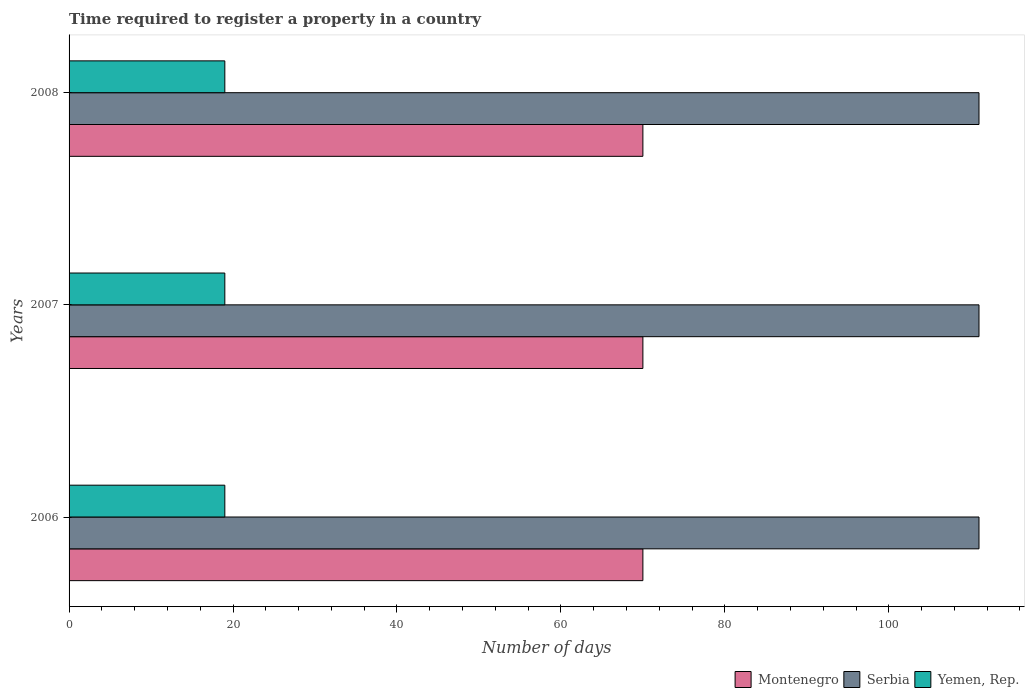How many different coloured bars are there?
Ensure brevity in your answer.  3. How many groups of bars are there?
Make the answer very short. 3. Are the number of bars per tick equal to the number of legend labels?
Your answer should be compact. Yes. Are the number of bars on each tick of the Y-axis equal?
Offer a very short reply. Yes. How many bars are there on the 2nd tick from the top?
Give a very brief answer. 3. How many bars are there on the 2nd tick from the bottom?
Offer a terse response. 3. In how many cases, is the number of bars for a given year not equal to the number of legend labels?
Make the answer very short. 0. What is the number of days required to register a property in Yemen, Rep. in 2006?
Make the answer very short. 19. Across all years, what is the maximum number of days required to register a property in Serbia?
Your answer should be very brief. 111. Across all years, what is the minimum number of days required to register a property in Serbia?
Ensure brevity in your answer.  111. What is the total number of days required to register a property in Yemen, Rep. in the graph?
Make the answer very short. 57. In the year 2008, what is the difference between the number of days required to register a property in Montenegro and number of days required to register a property in Serbia?
Provide a succinct answer. -41. In how many years, is the number of days required to register a property in Yemen, Rep. greater than 12 days?
Your answer should be very brief. 3. Is the number of days required to register a property in Serbia in 2007 less than that in 2008?
Provide a succinct answer. No. Is the difference between the number of days required to register a property in Montenegro in 2006 and 2008 greater than the difference between the number of days required to register a property in Serbia in 2006 and 2008?
Give a very brief answer. No. What is the difference between the highest and the lowest number of days required to register a property in Yemen, Rep.?
Offer a very short reply. 0. Is the sum of the number of days required to register a property in Yemen, Rep. in 2007 and 2008 greater than the maximum number of days required to register a property in Montenegro across all years?
Give a very brief answer. No. What does the 1st bar from the top in 2006 represents?
Your response must be concise. Yemen, Rep. What does the 3rd bar from the bottom in 2008 represents?
Provide a short and direct response. Yemen, Rep. Is it the case that in every year, the sum of the number of days required to register a property in Serbia and number of days required to register a property in Montenegro is greater than the number of days required to register a property in Yemen, Rep.?
Provide a short and direct response. Yes. What is the difference between two consecutive major ticks on the X-axis?
Offer a very short reply. 20. Does the graph contain grids?
Offer a terse response. No. Where does the legend appear in the graph?
Keep it short and to the point. Bottom right. How many legend labels are there?
Provide a succinct answer. 3. What is the title of the graph?
Ensure brevity in your answer.  Time required to register a property in a country. What is the label or title of the X-axis?
Ensure brevity in your answer.  Number of days. What is the label or title of the Y-axis?
Ensure brevity in your answer.  Years. What is the Number of days of Serbia in 2006?
Provide a succinct answer. 111. What is the Number of days of Yemen, Rep. in 2006?
Keep it short and to the point. 19. What is the Number of days in Montenegro in 2007?
Give a very brief answer. 70. What is the Number of days in Serbia in 2007?
Keep it short and to the point. 111. What is the Number of days of Montenegro in 2008?
Provide a succinct answer. 70. What is the Number of days in Serbia in 2008?
Ensure brevity in your answer.  111. Across all years, what is the maximum Number of days in Serbia?
Offer a terse response. 111. Across all years, what is the minimum Number of days of Montenegro?
Ensure brevity in your answer.  70. Across all years, what is the minimum Number of days in Serbia?
Provide a short and direct response. 111. Across all years, what is the minimum Number of days of Yemen, Rep.?
Provide a short and direct response. 19. What is the total Number of days of Montenegro in the graph?
Provide a short and direct response. 210. What is the total Number of days in Serbia in the graph?
Make the answer very short. 333. What is the difference between the Number of days in Montenegro in 2006 and that in 2007?
Make the answer very short. 0. What is the difference between the Number of days in Serbia in 2006 and that in 2007?
Your answer should be compact. 0. What is the difference between the Number of days of Yemen, Rep. in 2006 and that in 2007?
Your answer should be compact. 0. What is the difference between the Number of days of Montenegro in 2006 and that in 2008?
Offer a terse response. 0. What is the difference between the Number of days of Serbia in 2006 and that in 2008?
Your response must be concise. 0. What is the difference between the Number of days of Yemen, Rep. in 2006 and that in 2008?
Keep it short and to the point. 0. What is the difference between the Number of days in Montenegro in 2007 and that in 2008?
Your answer should be compact. 0. What is the difference between the Number of days of Yemen, Rep. in 2007 and that in 2008?
Keep it short and to the point. 0. What is the difference between the Number of days of Montenegro in 2006 and the Number of days of Serbia in 2007?
Offer a very short reply. -41. What is the difference between the Number of days of Serbia in 2006 and the Number of days of Yemen, Rep. in 2007?
Provide a short and direct response. 92. What is the difference between the Number of days in Montenegro in 2006 and the Number of days in Serbia in 2008?
Offer a very short reply. -41. What is the difference between the Number of days of Serbia in 2006 and the Number of days of Yemen, Rep. in 2008?
Offer a terse response. 92. What is the difference between the Number of days in Montenegro in 2007 and the Number of days in Serbia in 2008?
Your answer should be compact. -41. What is the difference between the Number of days in Serbia in 2007 and the Number of days in Yemen, Rep. in 2008?
Offer a very short reply. 92. What is the average Number of days in Montenegro per year?
Provide a succinct answer. 70. What is the average Number of days of Serbia per year?
Offer a terse response. 111. What is the average Number of days in Yemen, Rep. per year?
Give a very brief answer. 19. In the year 2006, what is the difference between the Number of days of Montenegro and Number of days of Serbia?
Ensure brevity in your answer.  -41. In the year 2006, what is the difference between the Number of days of Serbia and Number of days of Yemen, Rep.?
Ensure brevity in your answer.  92. In the year 2007, what is the difference between the Number of days in Montenegro and Number of days in Serbia?
Your answer should be compact. -41. In the year 2007, what is the difference between the Number of days of Montenegro and Number of days of Yemen, Rep.?
Give a very brief answer. 51. In the year 2007, what is the difference between the Number of days of Serbia and Number of days of Yemen, Rep.?
Provide a succinct answer. 92. In the year 2008, what is the difference between the Number of days of Montenegro and Number of days of Serbia?
Keep it short and to the point. -41. In the year 2008, what is the difference between the Number of days of Serbia and Number of days of Yemen, Rep.?
Offer a very short reply. 92. What is the ratio of the Number of days of Montenegro in 2006 to that in 2007?
Ensure brevity in your answer.  1. What is the ratio of the Number of days of Yemen, Rep. in 2006 to that in 2007?
Your answer should be very brief. 1. What is the ratio of the Number of days of Montenegro in 2006 to that in 2008?
Your answer should be very brief. 1. What is the ratio of the Number of days in Serbia in 2007 to that in 2008?
Provide a succinct answer. 1. What is the ratio of the Number of days of Yemen, Rep. in 2007 to that in 2008?
Your answer should be compact. 1. What is the difference between the highest and the second highest Number of days of Montenegro?
Provide a succinct answer. 0. What is the difference between the highest and the second highest Number of days in Yemen, Rep.?
Your answer should be compact. 0. What is the difference between the highest and the lowest Number of days of Serbia?
Offer a very short reply. 0. 